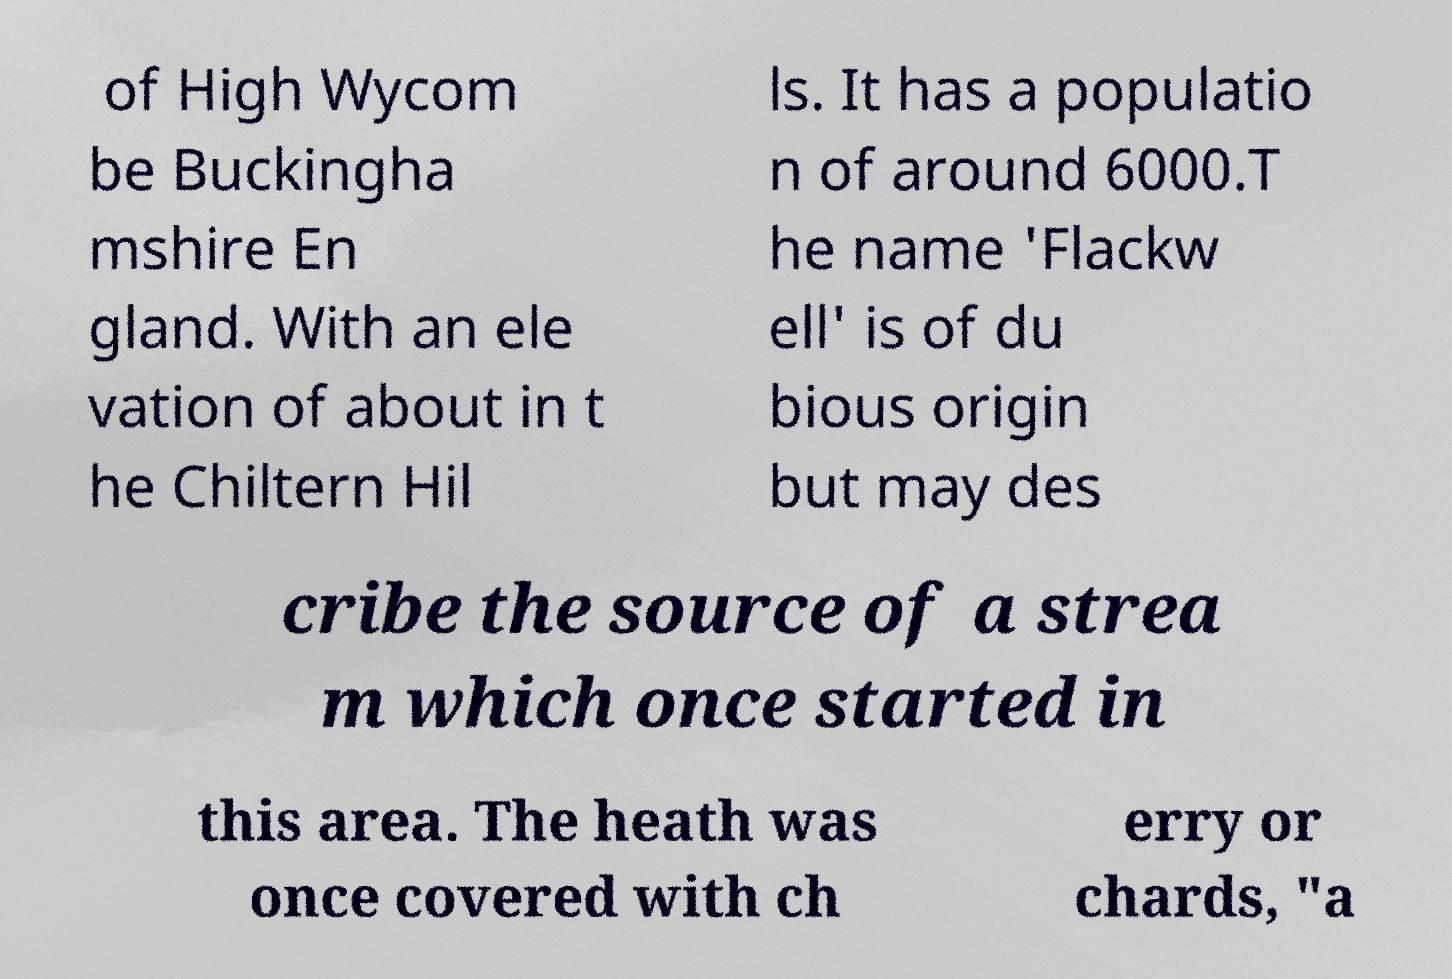Could you extract and type out the text from this image? of High Wycom be Buckingha mshire En gland. With an ele vation of about in t he Chiltern Hil ls. It has a populatio n of around 6000.T he name 'Flackw ell' is of du bious origin but may des cribe the source of a strea m which once started in this area. The heath was once covered with ch erry or chards, "a 